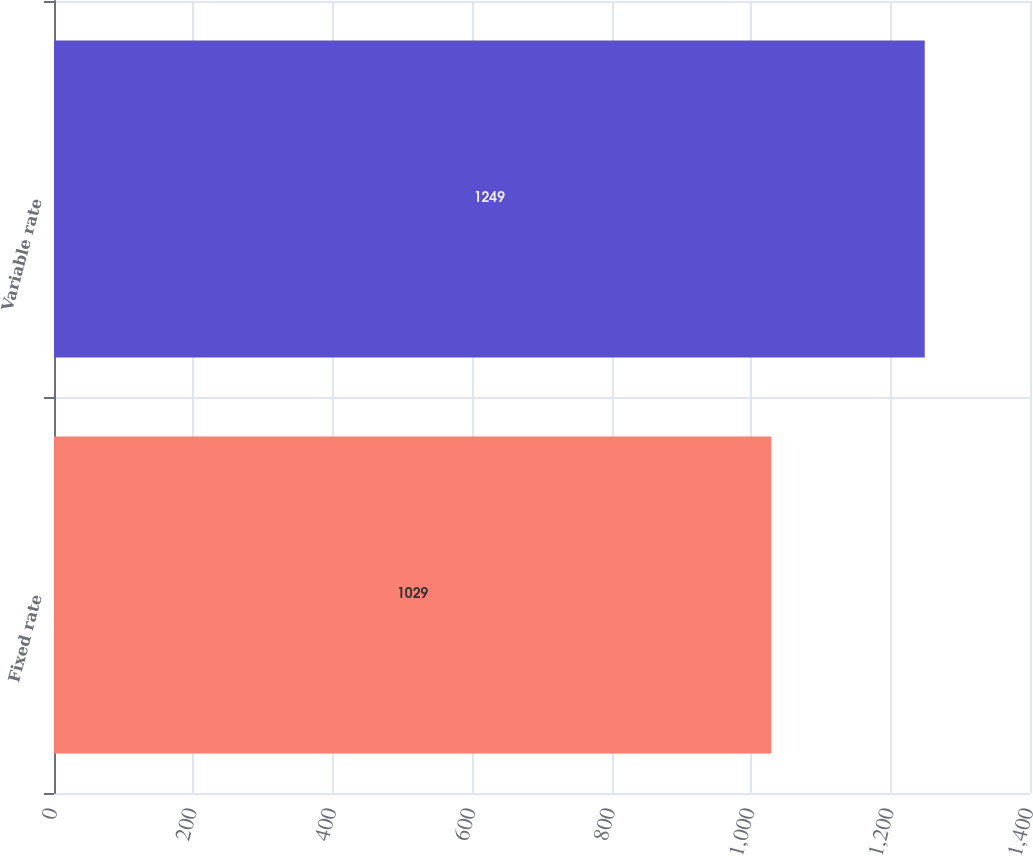Convert chart. <chart><loc_0><loc_0><loc_500><loc_500><bar_chart><fcel>Fixed rate<fcel>Variable rate<nl><fcel>1029<fcel>1249<nl></chart> 